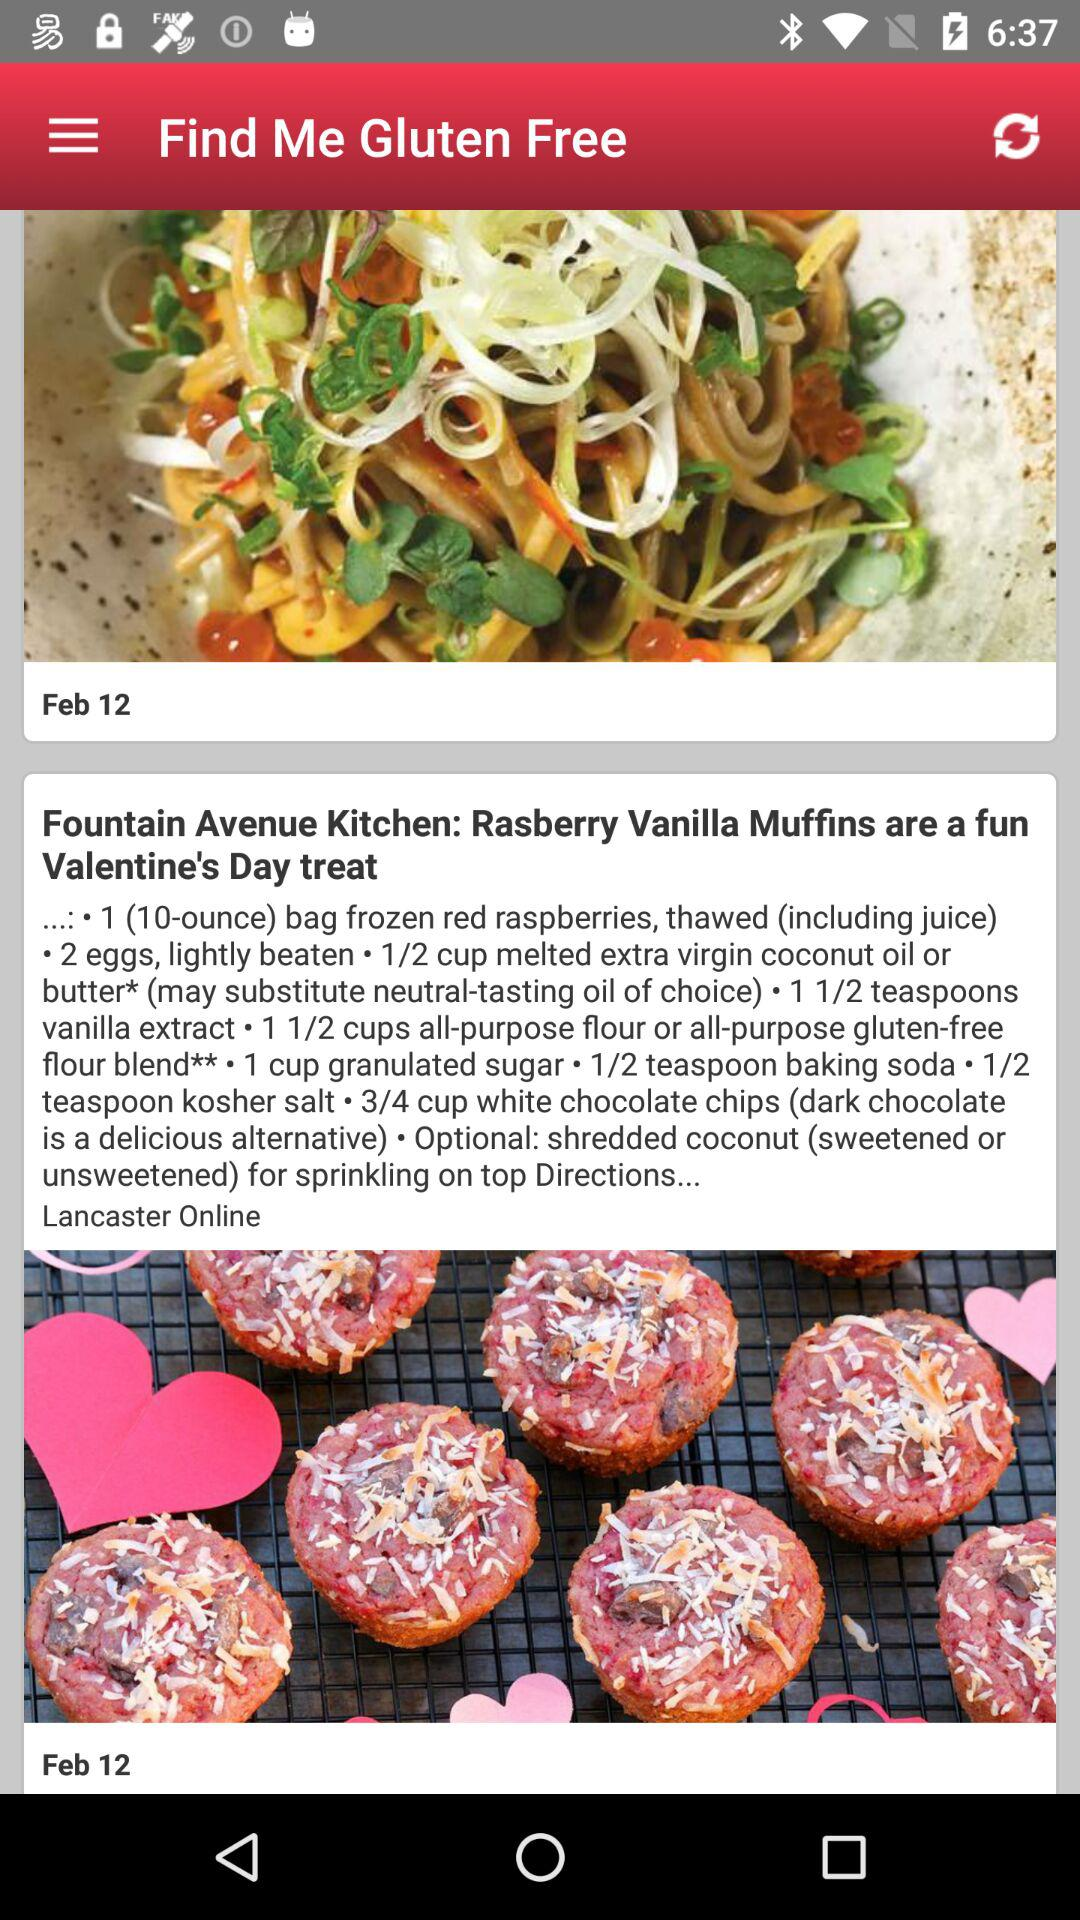How many teaspoons of baking soda are needed for the dish? For the dish, half a teaspoon of baking soda is needed. 